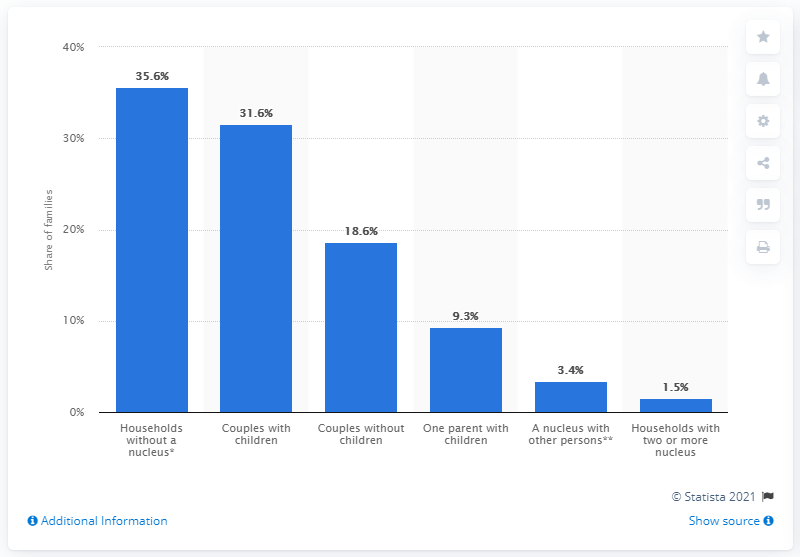Specify some key components in this picture. In 2019, approximately 35.6% of all households in Italy lacked a nucleus. 